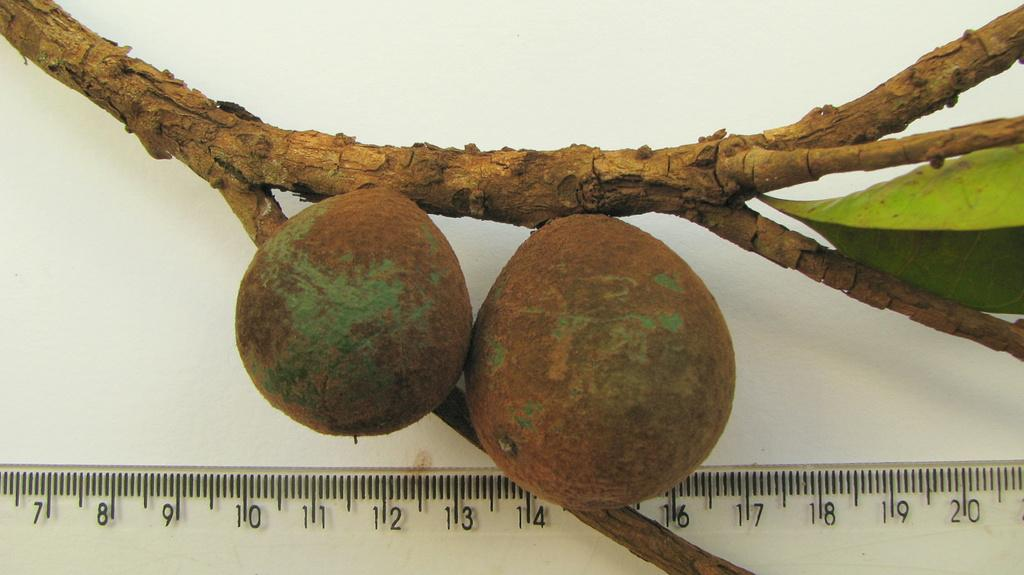<image>
Render a clear and concise summary of the photo. Fruit being measured by a ruler that goes up to 20. 